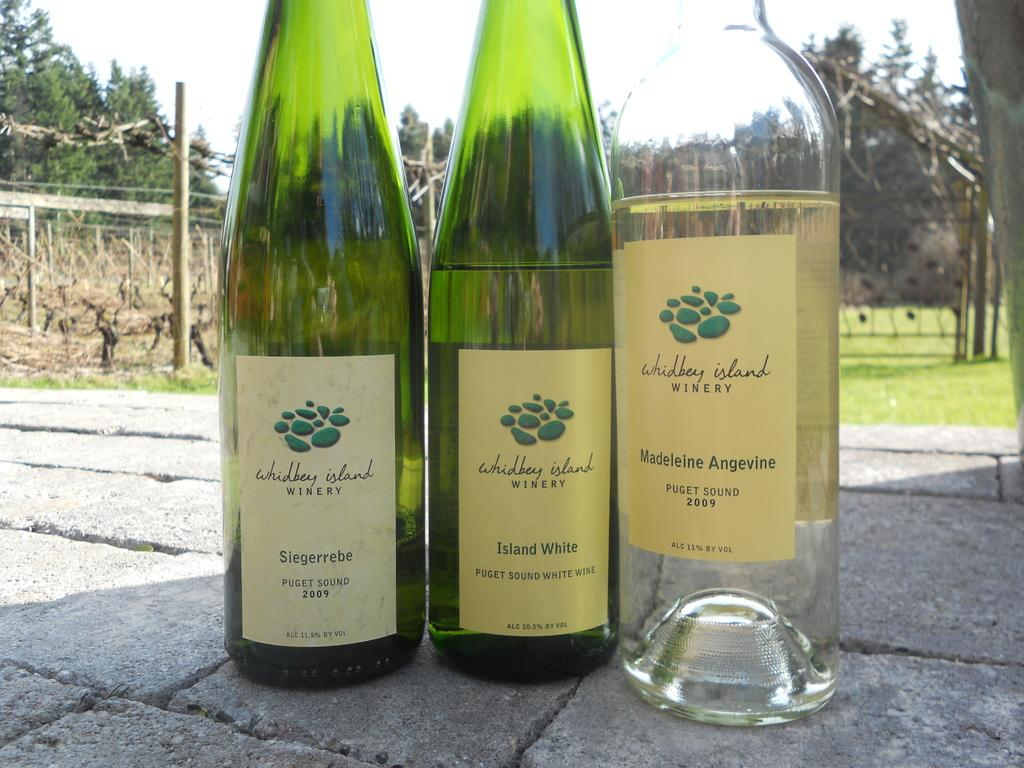<image>
Create a compact narrative representing the image presented. Three bottles from the Whidbey island winery on the ground outside. 